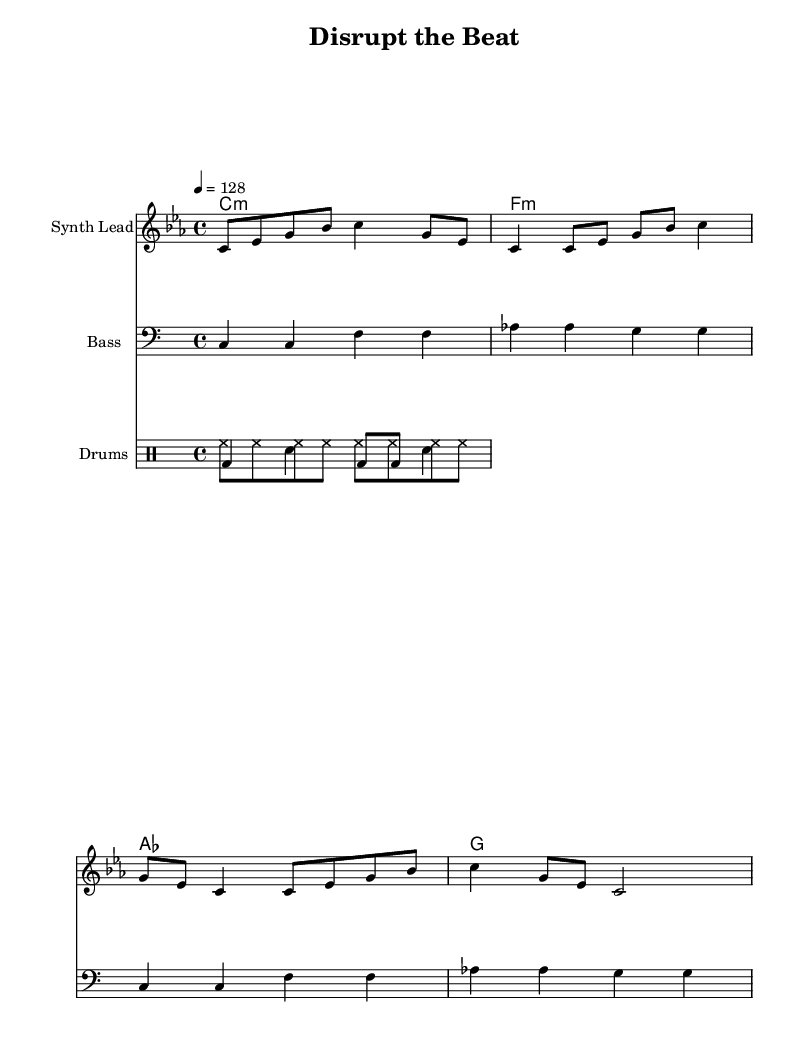What is the key signature of this music? The key signature is C minor, which has three flats: B flat, E flat, and A flat. This can be identified from the key indicated at the beginning of the score.
Answer: C minor What is the time signature of this music? The time signature is 4/4, which means there are four beats in each measure and a quarter note receives one beat. This is shown at the beginning of the score right after the key signature.
Answer: 4/4 What is the tempo of this piece? The tempo is set at 128 beats per minute (bpm), as indicated by the tempo marking at the beginning of the score. This specifies the speed of the music.
Answer: 128 What instrument is featured as the synth lead? The staff labeled as "Synth Lead" represents the primary melodic instrument, which plays a series of notes that create the main theme of the piece. This is explicitly stated in the score.
Answer: Synth Lead How many measures are in the melody? The melody consists of 4 measures, which can be counted from the musical notation presented, where each measure is separated by vertical lines. Thus, identifying each measure allows one to determine the total.
Answer: 4 What type of rhythm pattern is used in the drum section? The drum section contains a hi-hat rhythm played in eighth notes and a bass drum-snare pattern that varies throughout the measures, creating a typical dance music feel with an energetic pulse. By analyzing the drum lines, this can be determined.
Answer: Hi-hat and bass-snare What is the harmonic structure of the piece? The piece has a harmonic structure that follows a chord progression consisting of minor chords primarily in the key of C minor, transitioning between specific chords. This can be seen in the chord names written above the staff.
Answer: C minor, F minor, A flat, G 